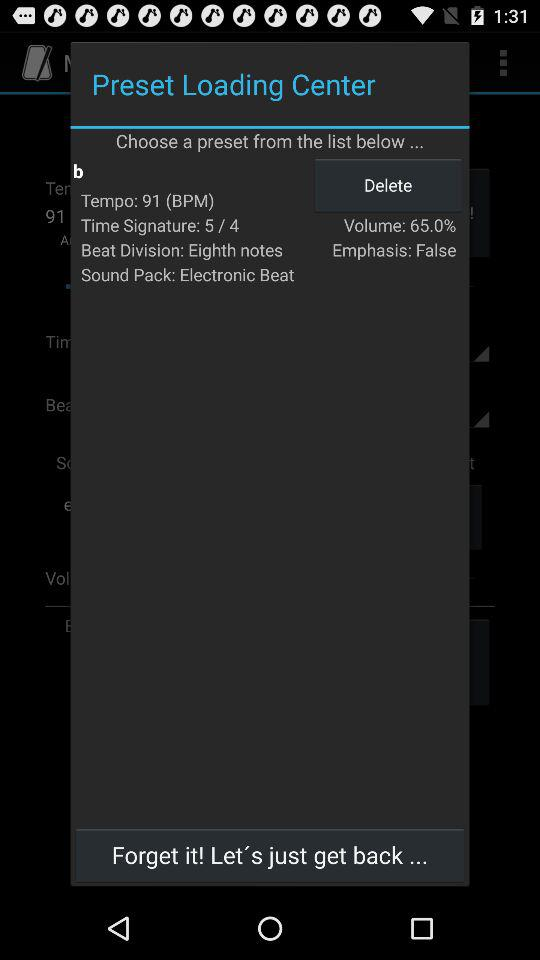What is the number for the tempo? The number for the tempo is 91. 